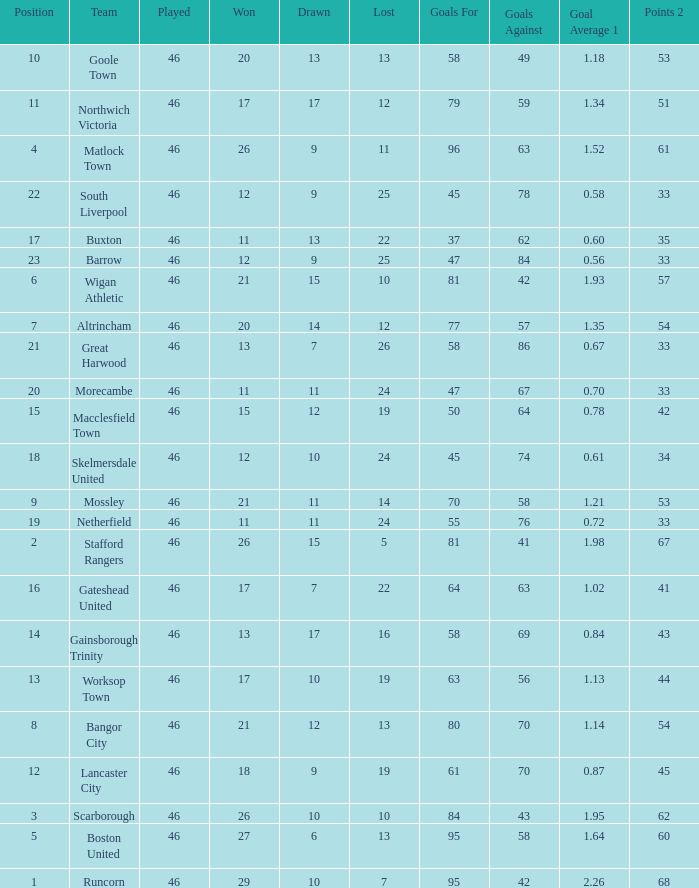List all losses with average goals of 1.21. 14.0. 